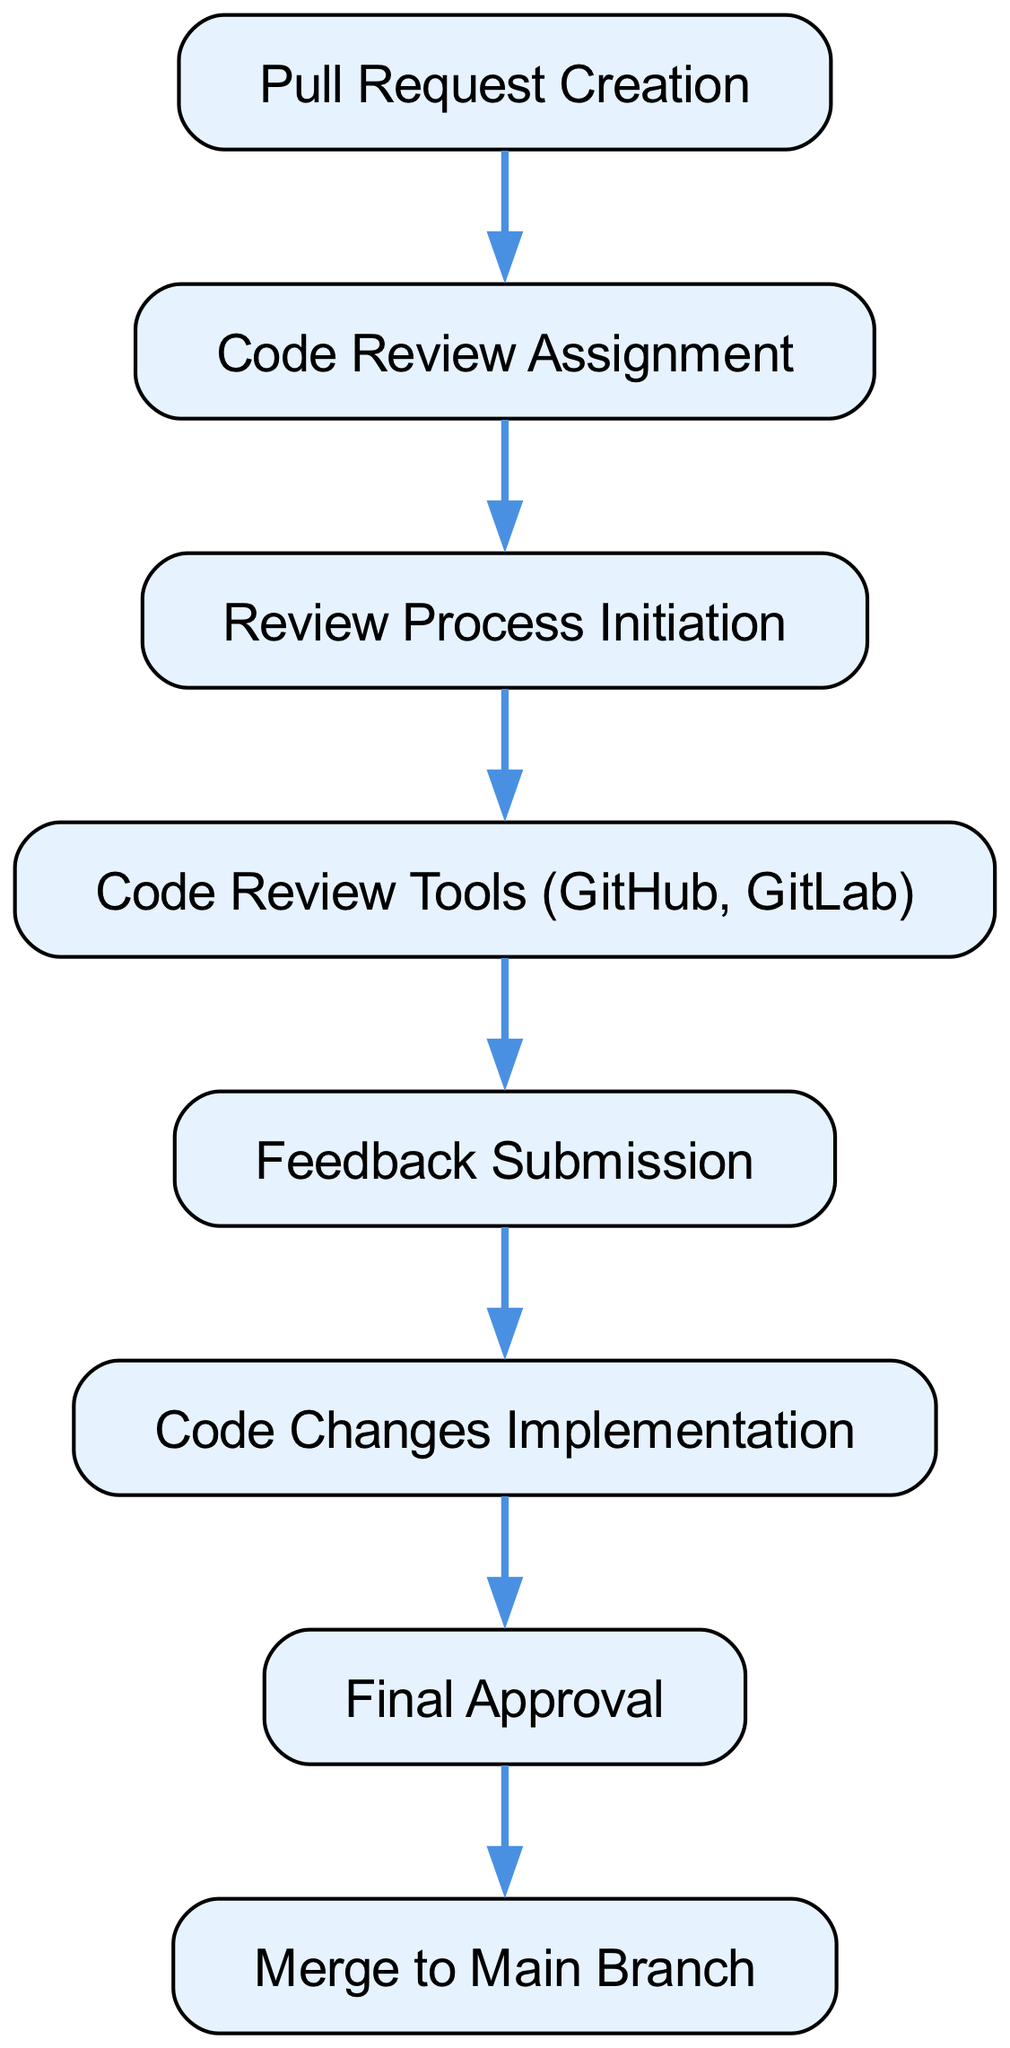What is the first step in the code review process? The first node in the diagram is "Pull Request Creation", which indicates that this is the starting point of the code review process.
Answer: Pull Request Creation How many nodes are present in the diagram? By counting the nodes listed in the JSON data, there are a total of 8 nodes that illustrate the various steps in the code review process.
Answer: 8 What is the last step before merging to the main branch? From the directed flow in the diagram, the last step before merging is "Final Approval". This indicates that final approval must be obtained prior to merging the changes.
Answer: Final Approval Which tools are associated with the code review process? The node labeled "Code Review Tools (GitHub, GitLab)" indicates the specific tools used in the review process as shown in the diagram.
Answer: GitHub, GitLab What is the relationship between "Feedback Submission" and "Code Changes Implementation"? According to the edges in the diagram, "Feedback Submission" leads directly to "Code Changes Implementation", showing that feedback must be acted upon before changes can be made.
Answer: Directly leads to What comes after the "Review Process Initiation"? In following the directed edges in the diagram, the step that comes immediately after "Review Process Initiation" is "Code Review Tools (GitHub, GitLab)".
Answer: Code Review Tools (GitHub, GitLab) Which step requires input before the "Final Approval"? Prior to reaching "Final Approval", the step that needs to take place is "Code Changes Implementation", as it is essential for addressing the review feedback before final approval can occur.
Answer: Code Changes Implementation How many edges connect the nodes in this diagram? By counting the connections (edges) listed in the JSON data, there are 7 edges that show the directional flow between the nodes in the code review process.
Answer: 7 